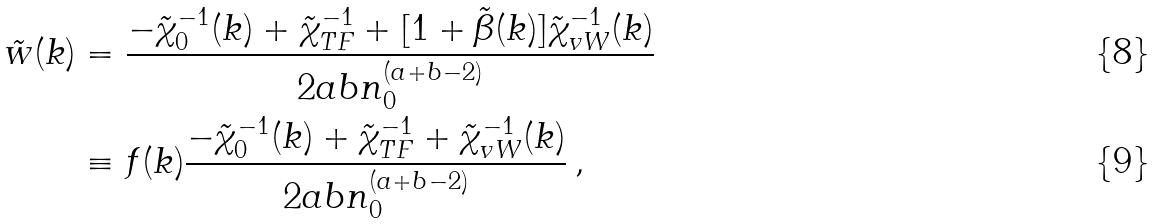Convert formula to latex. <formula><loc_0><loc_0><loc_500><loc_500>\tilde { w } ( k ) & = \frac { - \tilde { \chi } _ { 0 } ^ { - 1 } ( k ) + \tilde { \chi } _ { T F } ^ { - 1 } + [ 1 + \tilde { \beta } ( k ) ] \tilde { \chi } _ { v W } ^ { - 1 } ( k ) } { 2 a b n _ { 0 } ^ { ( a + b - 2 ) } } \\ & \equiv f ( k ) \frac { - \tilde { \chi } _ { 0 } ^ { - 1 } ( k ) + \tilde { \chi } _ { T F } ^ { - 1 } + \tilde { \chi } _ { v W } ^ { - 1 } ( k ) } { 2 a b n _ { 0 } ^ { ( a + b - 2 ) } } \, ,</formula> 